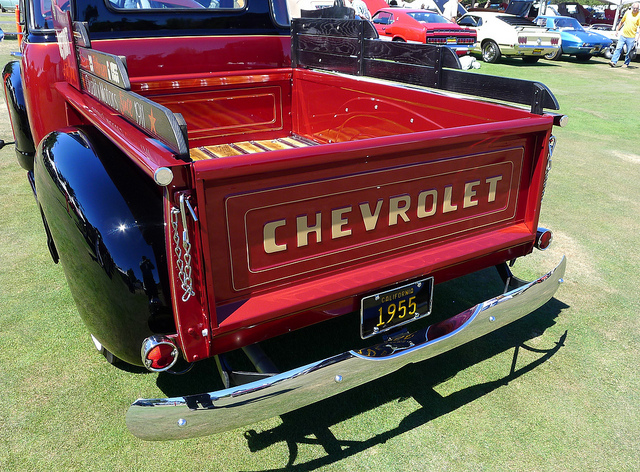Extract all visible text content from this image. CHEVROLET 5 1955 